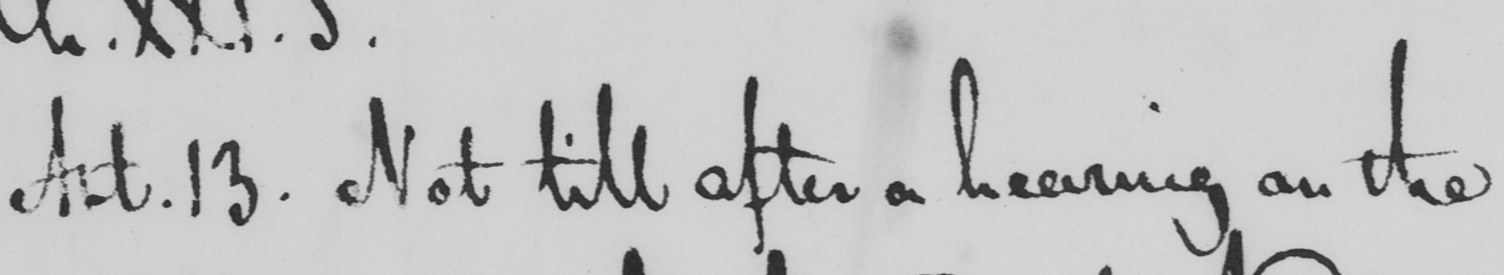Transcribe the text shown in this historical manuscript line. Art . 13 . Not till after a hearing on the 